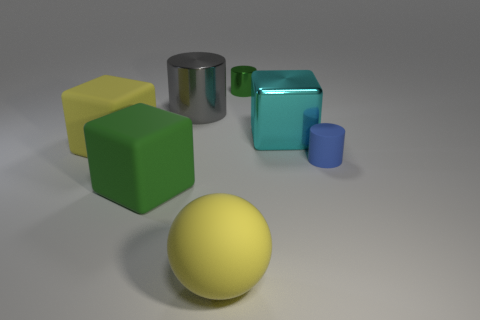Do the yellow rubber thing behind the blue thing and the large gray metallic thing have the same shape?
Give a very brief answer. No. What is the shape of the green thing that is right of the shiny cylinder left of the tiny green metallic thing?
Your answer should be very brief. Cylinder. There is a yellow object that is in front of the green thing that is left of the tiny thing behind the big gray object; how big is it?
Offer a terse response. Large. What is the color of the large object that is the same shape as the tiny rubber object?
Keep it short and to the point. Gray. Does the yellow rubber ball have the same size as the yellow cube?
Your answer should be compact. Yes. What is the cube behind the large yellow cube made of?
Your response must be concise. Metal. How many other objects are there of the same shape as the gray object?
Make the answer very short. 2. Is the big green matte object the same shape as the gray metal object?
Keep it short and to the point. No. There is a big cyan object; are there any matte cubes behind it?
Keep it short and to the point. No. How many things are purple rubber spheres or metallic cylinders?
Keep it short and to the point. 2. 